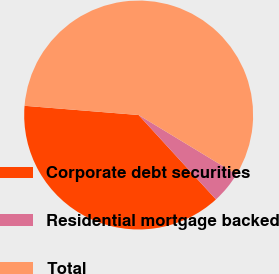Convert chart to OTSL. <chart><loc_0><loc_0><loc_500><loc_500><pie_chart><fcel>Corporate debt securities<fcel>Residential mortgage backed<fcel>Total<nl><fcel>38.09%<fcel>4.52%<fcel>57.39%<nl></chart> 